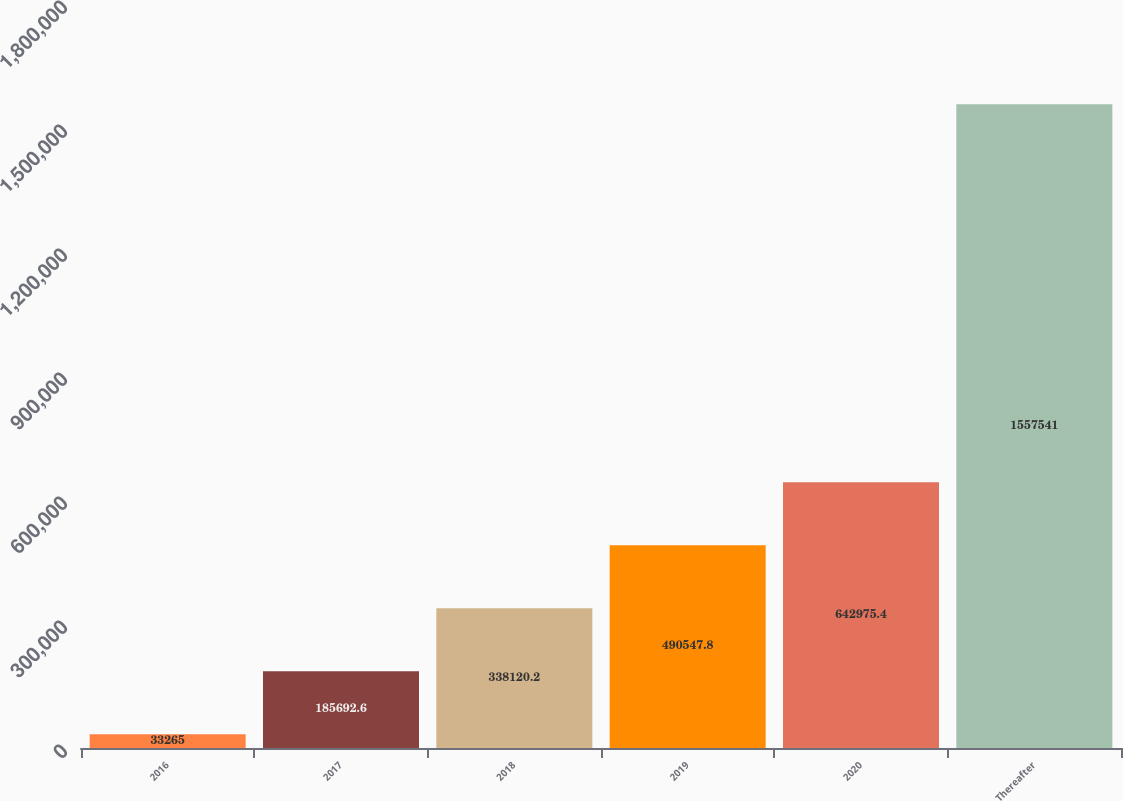Convert chart. <chart><loc_0><loc_0><loc_500><loc_500><bar_chart><fcel>2016<fcel>2017<fcel>2018<fcel>2019<fcel>2020<fcel>Thereafter<nl><fcel>33265<fcel>185693<fcel>338120<fcel>490548<fcel>642975<fcel>1.55754e+06<nl></chart> 